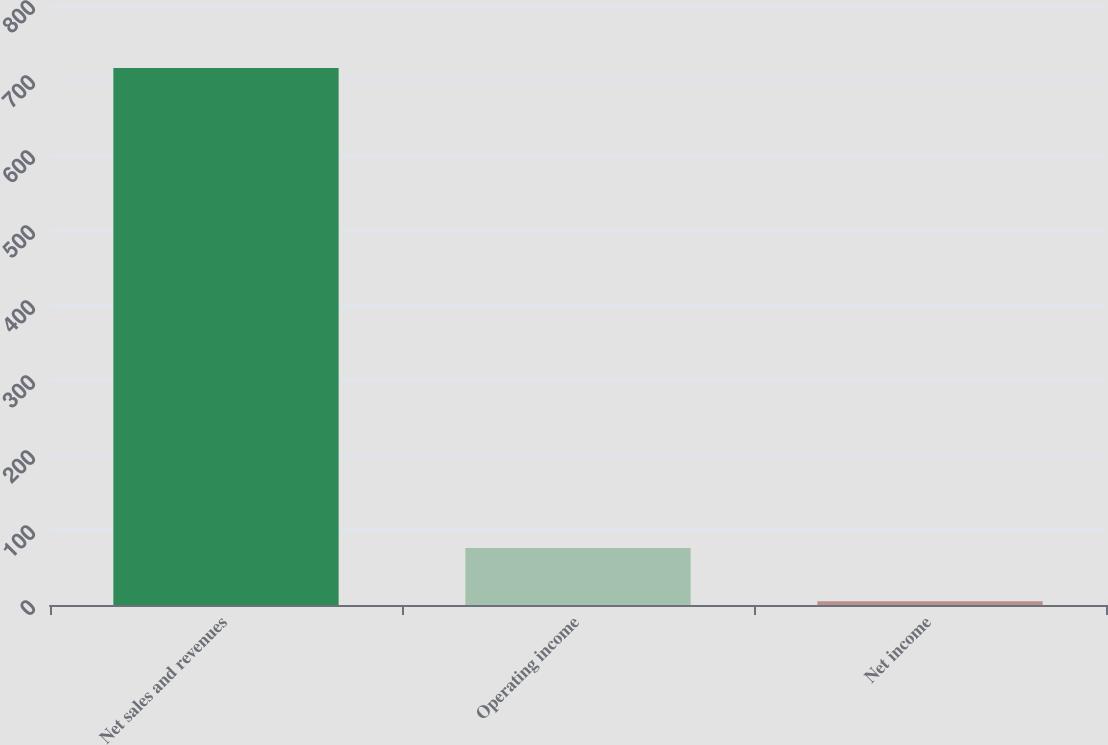<chart> <loc_0><loc_0><loc_500><loc_500><bar_chart><fcel>Net sales and revenues<fcel>Operating income<fcel>Net income<nl><fcel>716<fcel>76.1<fcel>5<nl></chart> 